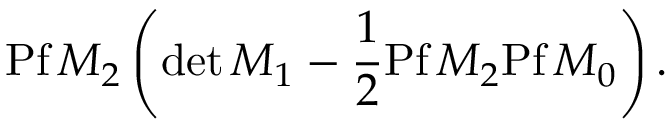Convert formula to latex. <formula><loc_0><loc_0><loc_500><loc_500>P f \, M _ { 2 } \left ( d e t \, M _ { 1 } - \frac { 1 } { 2 } P f \, M _ { 2 } P f \, M _ { 0 } \right ) .</formula> 